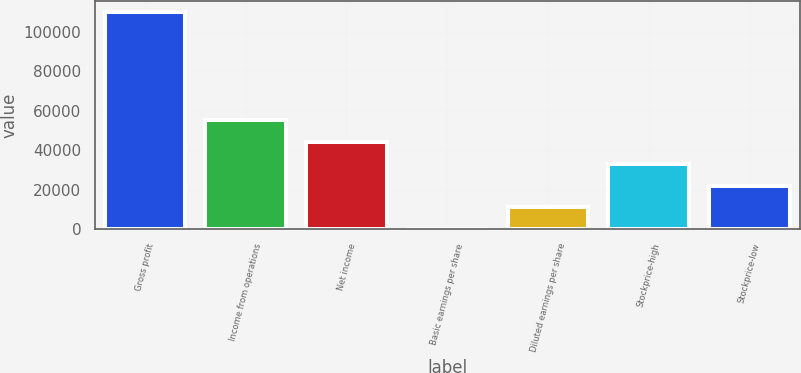Convert chart. <chart><loc_0><loc_0><loc_500><loc_500><bar_chart><fcel>Gross profit<fcel>Income from operations<fcel>Net income<fcel>Basic earnings per share<fcel>Diluted earnings per share<fcel>Stockprice-high<fcel>Stockprice-low<nl><fcel>110008<fcel>55004.1<fcel>44003.4<fcel>0.25<fcel>11001<fcel>33002.6<fcel>22001.8<nl></chart> 